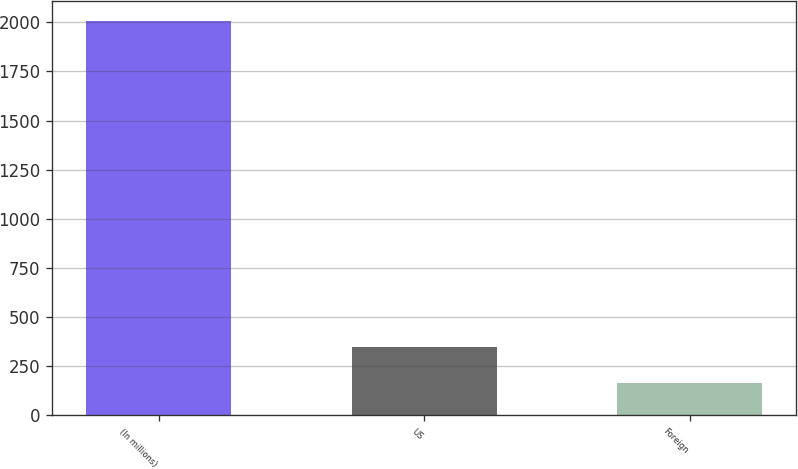<chart> <loc_0><loc_0><loc_500><loc_500><bar_chart><fcel>(In millions)<fcel>US<fcel>Foreign<nl><fcel>2007<fcel>348.3<fcel>164<nl></chart> 